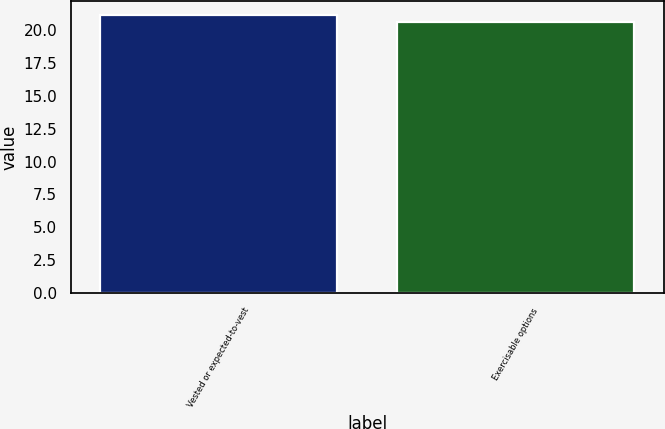Convert chart to OTSL. <chart><loc_0><loc_0><loc_500><loc_500><bar_chart><fcel>Vested or expected-to-vest<fcel>Exercisable options<nl><fcel>21.13<fcel>20.59<nl></chart> 